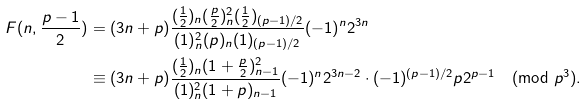<formula> <loc_0><loc_0><loc_500><loc_500>F ( n , \frac { p - 1 } 2 ) & = ( 3 n + p ) \frac { ( \frac { 1 } { 2 } ) _ { n } ( \frac { p } { 2 } ) _ { n } ^ { 2 } ( \frac { 1 } { 2 } ) _ { ( p - 1 ) / 2 } } { ( 1 ) _ { n } ^ { 2 } ( p ) _ { n } ( 1 ) _ { ( p - 1 ) / 2 } } ( - 1 ) ^ { n } 2 ^ { 3 n } \\ & \equiv ( 3 n + p ) \frac { ( \frac { 1 } { 2 } ) _ { n } ( 1 + \frac { p } { 2 } ) _ { n - 1 } ^ { 2 } } { ( 1 ) _ { n } ^ { 2 } ( 1 + p ) _ { n - 1 } } ( - 1 ) ^ { n } 2 ^ { 3 n - 2 } \cdot ( - 1 ) ^ { ( p - 1 ) / 2 } p 2 ^ { p - 1 } \pmod { p ^ { 3 } } .</formula> 